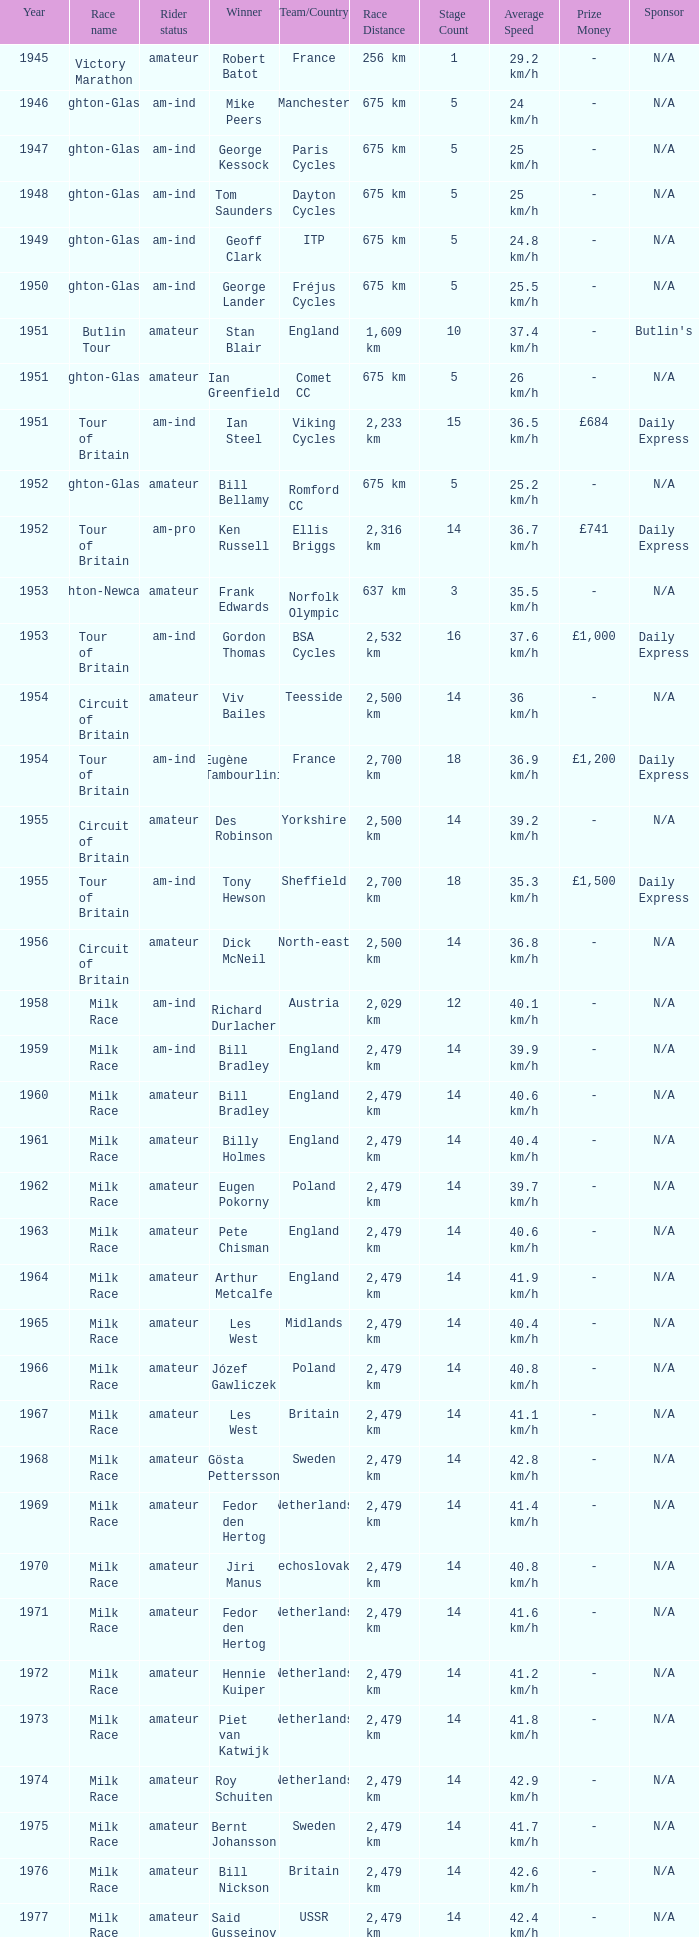What is the latest year when Phil Anderson won? 1993.0. 